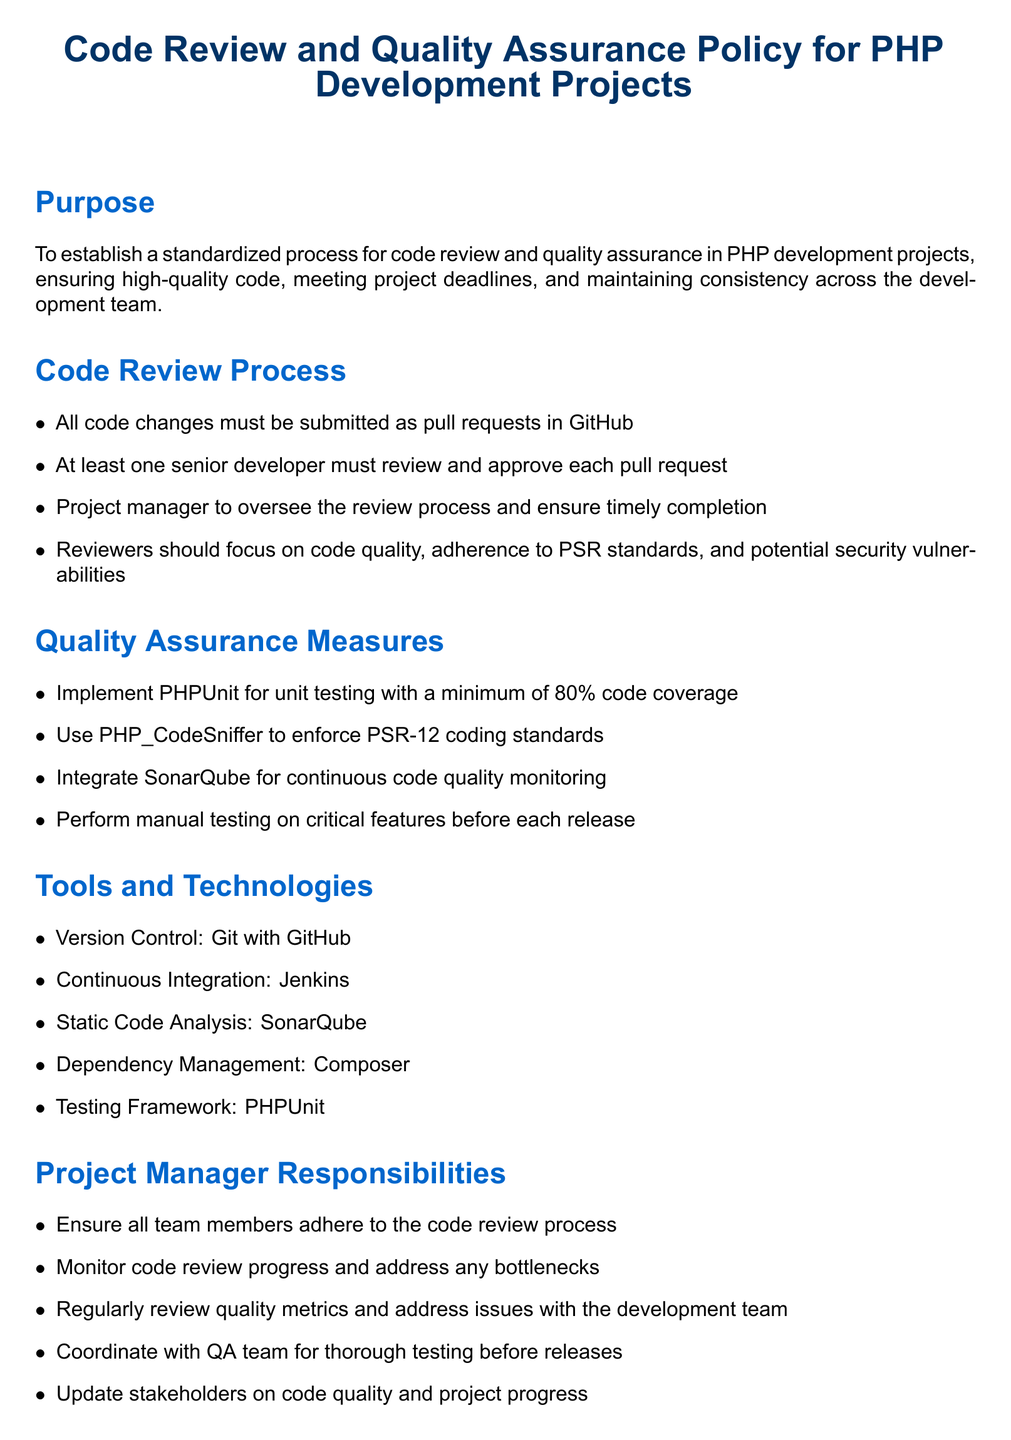What is the purpose of the policy? The purpose is to establish a standardized process for code review and quality assurance in PHP development projects, ensuring high-quality code, meeting project deadlines, and maintaining consistency across the development team.
Answer: Establish a standardized process for code review and quality assurance How many senior developers must review each pull request? The document states that at least one senior developer must review and approve each pull request.
Answer: At least one senior developer What testing framework is used for unit testing? The document specifies PHPUnit as the testing framework used for unit testing in PHP development projects.
Answer: PHPUnit What is the minimum code coverage required? The policy states that a minimum of 80% code coverage is required for unit testing.
Answer: 80% What tool is used for continuous code quality monitoring? The document mentions SonarQube as the tool for continuous code quality monitoring.
Answer: SonarQube What is the project manager responsible for? The responsibilities of the project manager include ensuring adherence to the code review process and monitoring progress.
Answer: Ensure adherence to code review process and monitor progress What may happen if the policy is not complied with? The consequences of non-compliance include project delays or code being rejected.
Answer: Project delays or code being rejected 